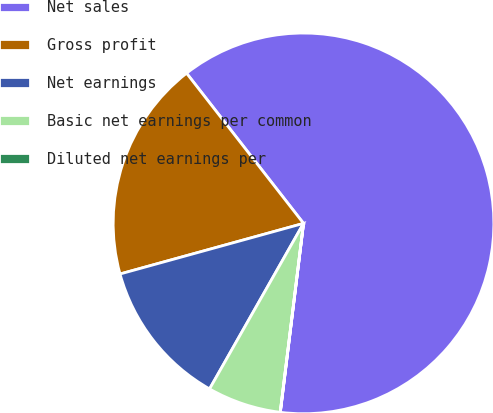Convert chart to OTSL. <chart><loc_0><loc_0><loc_500><loc_500><pie_chart><fcel>Net sales<fcel>Gross profit<fcel>Net earnings<fcel>Basic net earnings per common<fcel>Diluted net earnings per<nl><fcel>62.47%<fcel>18.75%<fcel>12.5%<fcel>6.26%<fcel>0.01%<nl></chart> 